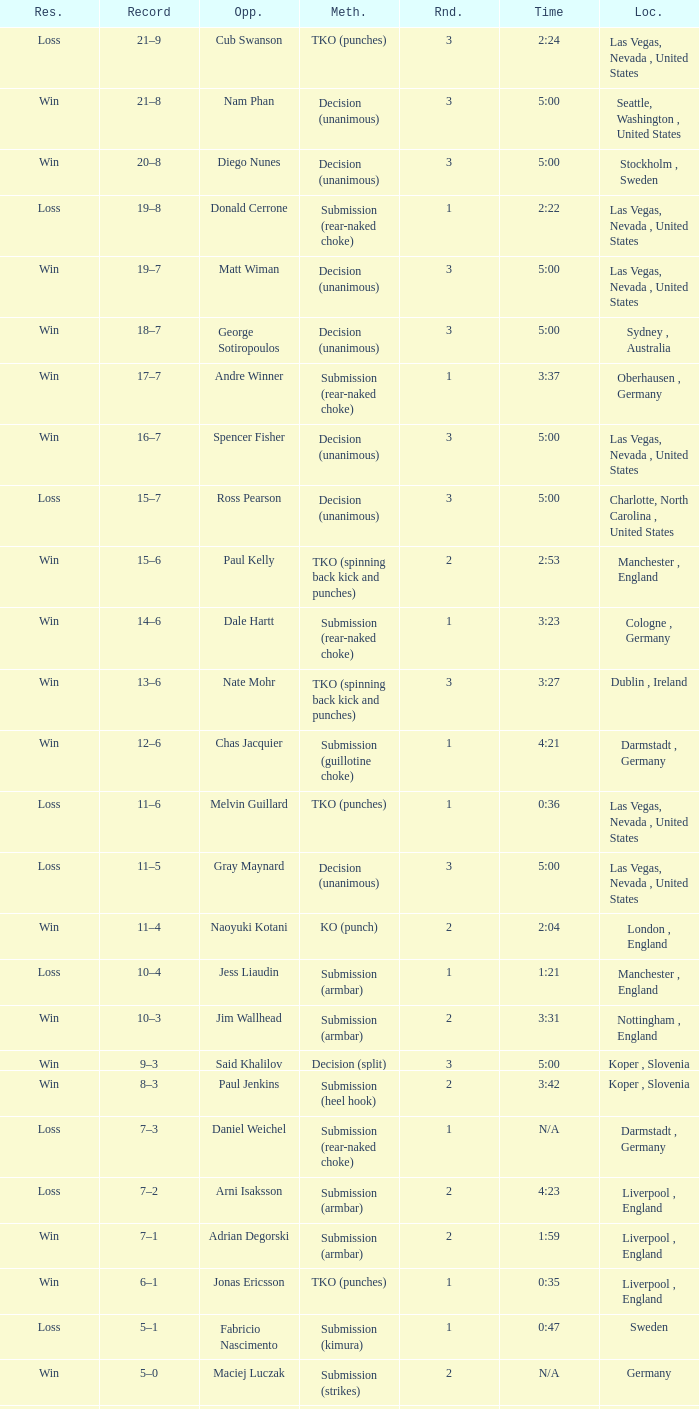What was the method of resolution for the fight against dale hartt? Submission (rear-naked choke). 